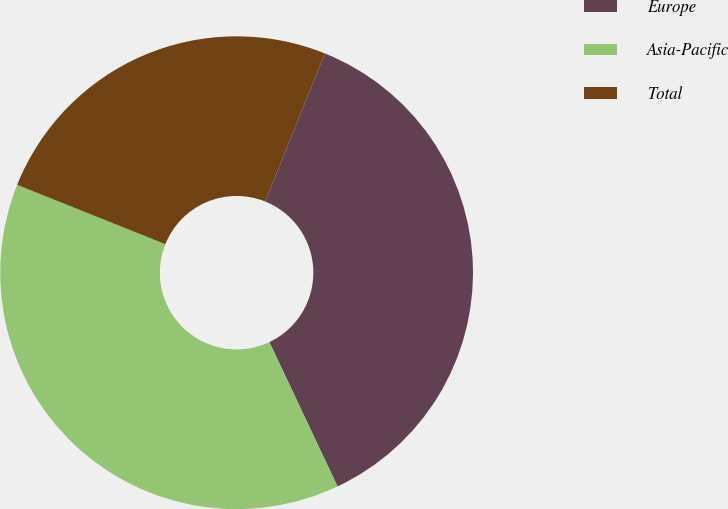Convert chart. <chart><loc_0><loc_0><loc_500><loc_500><pie_chart><fcel>Europe<fcel>Asia-Pacific<fcel>Total<nl><fcel>36.89%<fcel>38.08%<fcel>25.03%<nl></chart> 